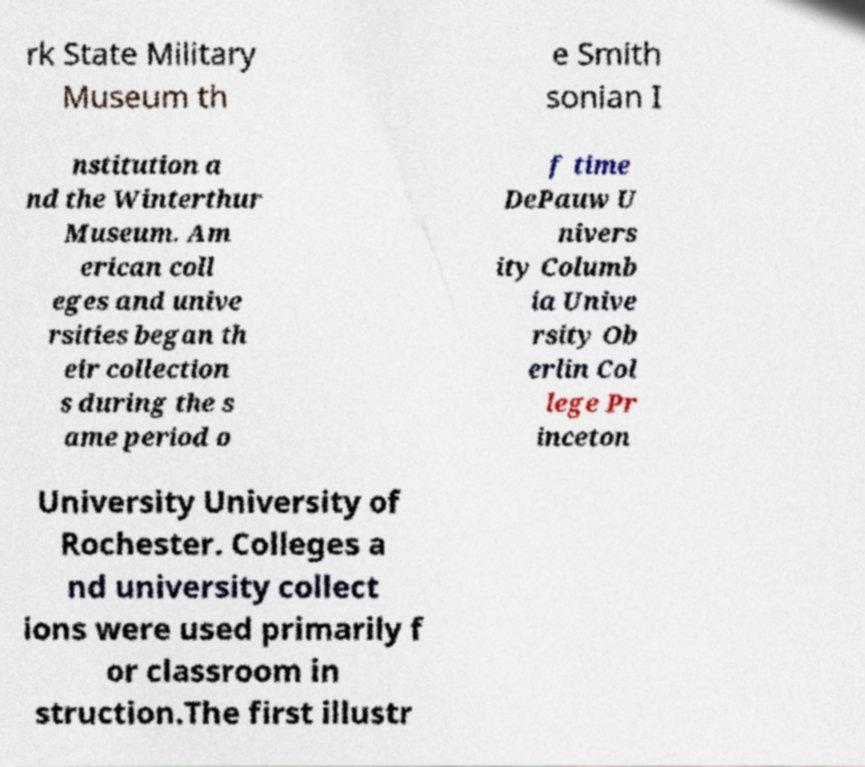I need the written content from this picture converted into text. Can you do that? rk State Military Museum th e Smith sonian I nstitution a nd the Winterthur Museum. Am erican coll eges and unive rsities began th eir collection s during the s ame period o f time DePauw U nivers ity Columb ia Unive rsity Ob erlin Col lege Pr inceton University University of Rochester. Colleges a nd university collect ions were used primarily f or classroom in struction.The first illustr 